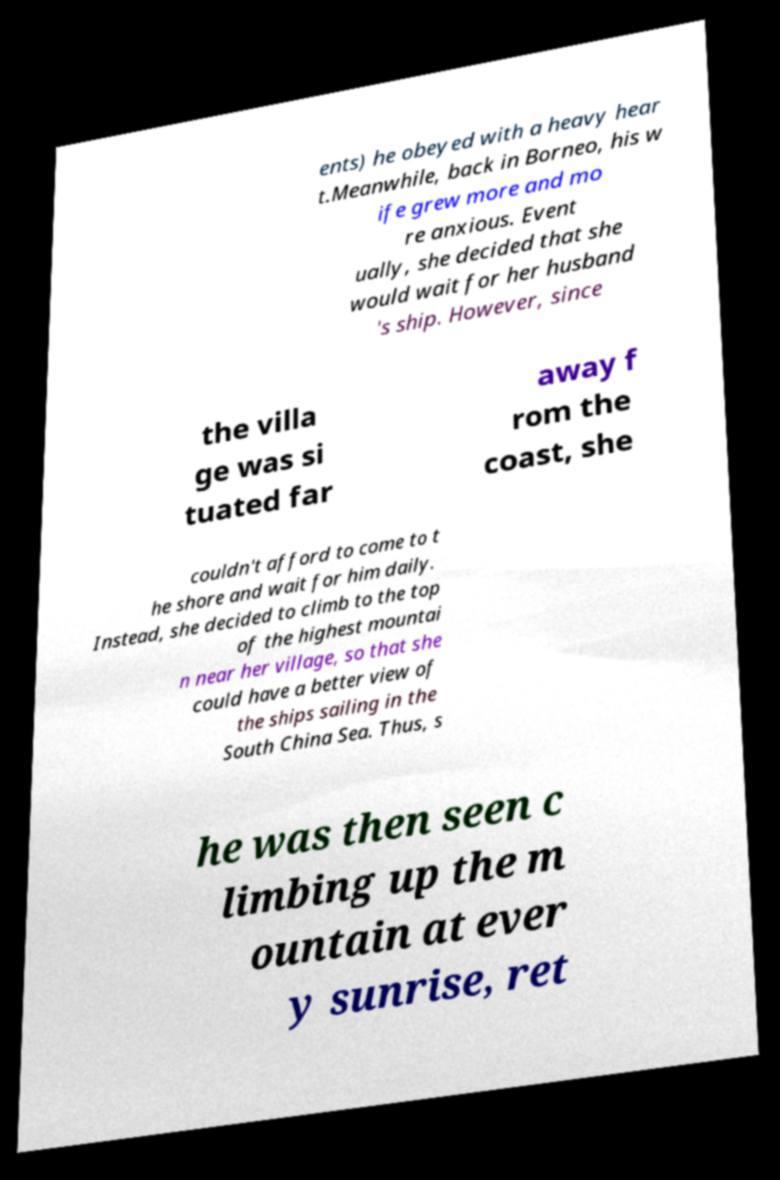What messages or text are displayed in this image? I need them in a readable, typed format. ents) he obeyed with a heavy hear t.Meanwhile, back in Borneo, his w ife grew more and mo re anxious. Event ually, she decided that she would wait for her husband 's ship. However, since the villa ge was si tuated far away f rom the coast, she couldn't afford to come to t he shore and wait for him daily. Instead, she decided to climb to the top of the highest mountai n near her village, so that she could have a better view of the ships sailing in the South China Sea. Thus, s he was then seen c limbing up the m ountain at ever y sunrise, ret 